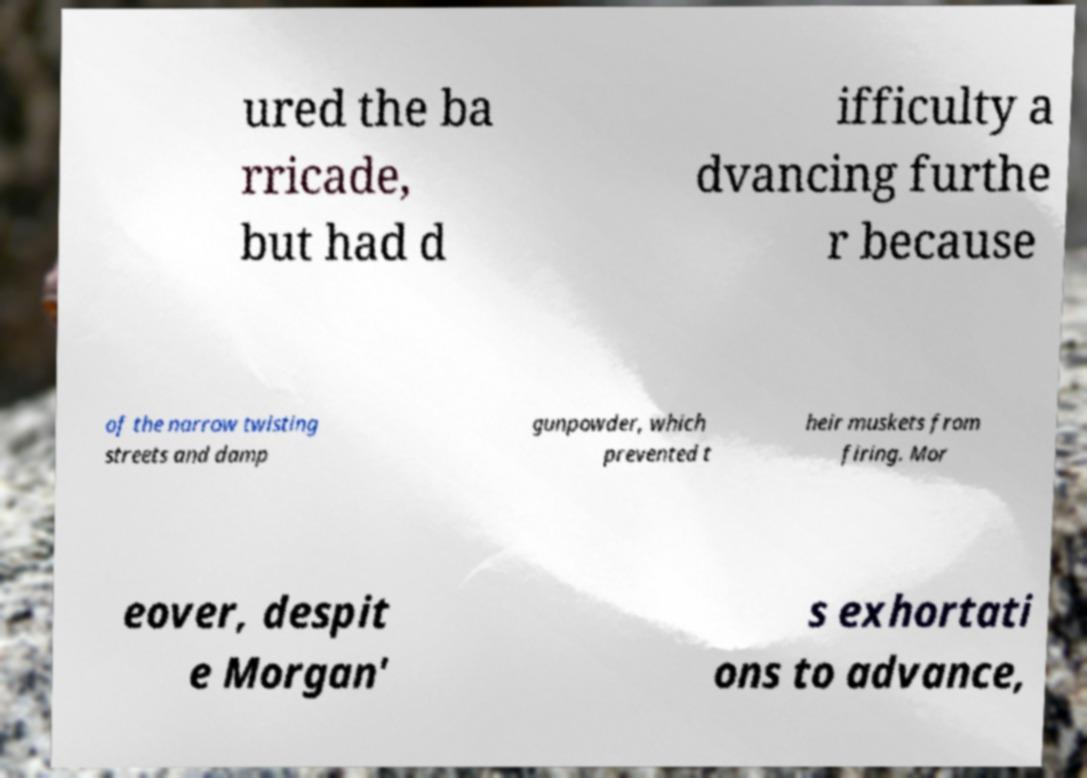Please identify and transcribe the text found in this image. ured the ba rricade, but had d ifficulty a dvancing furthe r because of the narrow twisting streets and damp gunpowder, which prevented t heir muskets from firing. Mor eover, despit e Morgan' s exhortati ons to advance, 